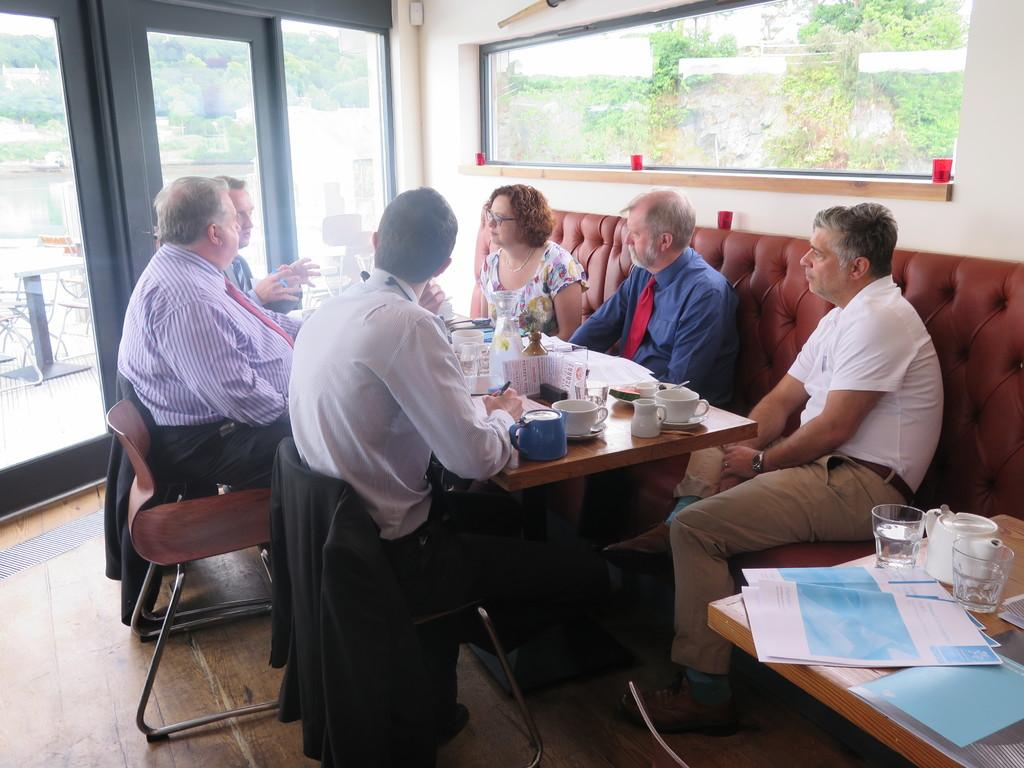How many people are in the image? There is a group of people in the image. What are the people doing in the image? The people are sitting in front of a table. What can be seen on the table in the image? The table has cups on it and papers on it. Where is the door located in the image? There is a door beside the group of people. What is visible in the background of the image? Trees are visible in the background of the image. How does the group of people tie a knot in the image? There is no knot-tying activity depicted in the image; the people are sitting in front of a table with cups and papers. 